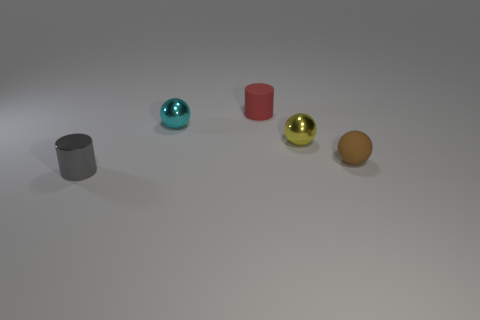Subtract all small shiny balls. How many balls are left? 1 Add 3 brown rubber balls. How many objects exist? 8 Subtract all spheres. How many objects are left? 2 Add 5 small matte cylinders. How many small matte cylinders are left? 6 Add 4 large yellow metallic cubes. How many large yellow metallic cubes exist? 4 Subtract 0 yellow blocks. How many objects are left? 5 Subtract all small rubber spheres. Subtract all gray objects. How many objects are left? 3 